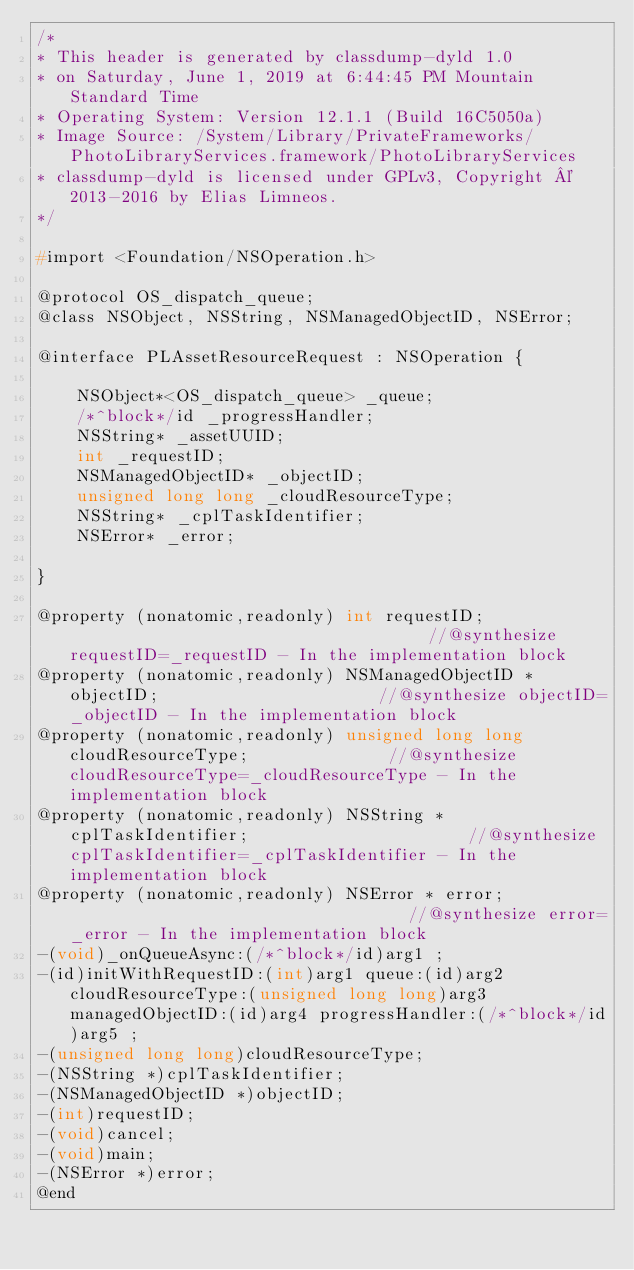Convert code to text. <code><loc_0><loc_0><loc_500><loc_500><_C_>/*
* This header is generated by classdump-dyld 1.0
* on Saturday, June 1, 2019 at 6:44:45 PM Mountain Standard Time
* Operating System: Version 12.1.1 (Build 16C5050a)
* Image Source: /System/Library/PrivateFrameworks/PhotoLibraryServices.framework/PhotoLibraryServices
* classdump-dyld is licensed under GPLv3, Copyright © 2013-2016 by Elias Limneos.
*/

#import <Foundation/NSOperation.h>

@protocol OS_dispatch_queue;
@class NSObject, NSString, NSManagedObjectID, NSError;

@interface PLAssetResourceRequest : NSOperation {

	NSObject*<OS_dispatch_queue> _queue;
	/*^block*/id _progressHandler;
	NSString* _assetUUID;
	int _requestID;
	NSManagedObjectID* _objectID;
	unsigned long long _cloudResourceType;
	NSString* _cplTaskIdentifier;
	NSError* _error;

}

@property (nonatomic,readonly) int requestID;                                     //@synthesize requestID=_requestID - In the implementation block
@property (nonatomic,readonly) NSManagedObjectID * objectID;                      //@synthesize objectID=_objectID - In the implementation block
@property (nonatomic,readonly) unsigned long long cloudResourceType;              //@synthesize cloudResourceType=_cloudResourceType - In the implementation block
@property (nonatomic,readonly) NSString * cplTaskIdentifier;                      //@synthesize cplTaskIdentifier=_cplTaskIdentifier - In the implementation block
@property (nonatomic,readonly) NSError * error;                                   //@synthesize error=_error - In the implementation block
-(void)_onQueueAsync:(/*^block*/id)arg1 ;
-(id)initWithRequestID:(int)arg1 queue:(id)arg2 cloudResourceType:(unsigned long long)arg3 managedObjectID:(id)arg4 progressHandler:(/*^block*/id)arg5 ;
-(unsigned long long)cloudResourceType;
-(NSString *)cplTaskIdentifier;
-(NSManagedObjectID *)objectID;
-(int)requestID;
-(void)cancel;
-(void)main;
-(NSError *)error;
@end

</code> 